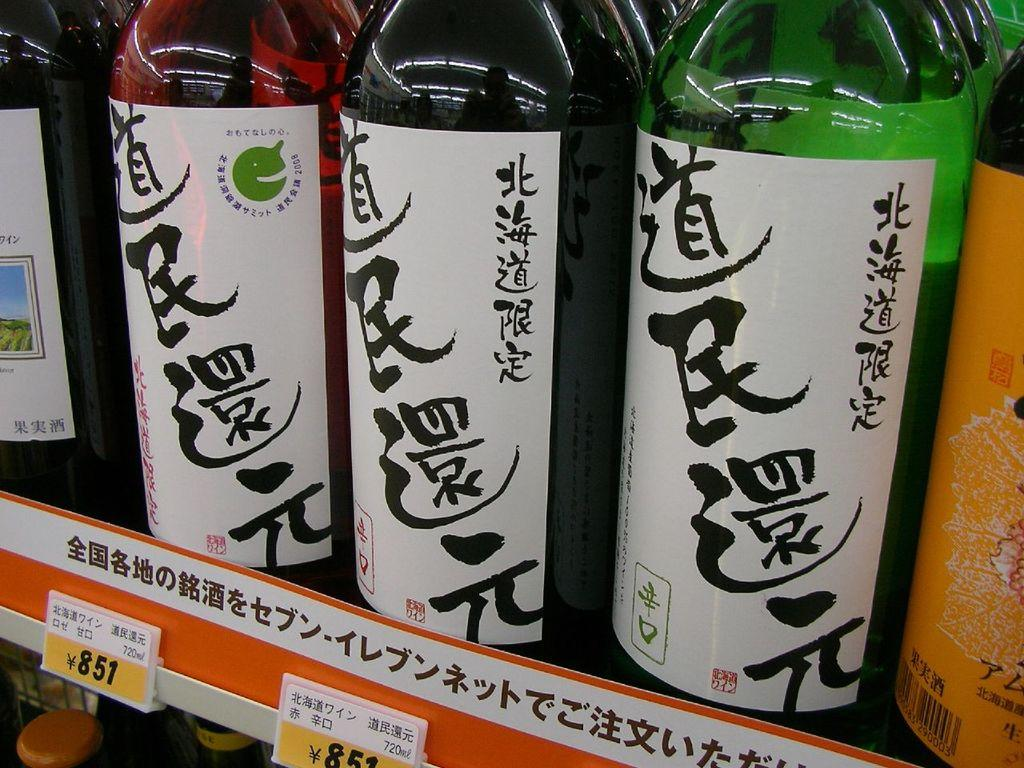<image>
Give a short and clear explanation of the subsequent image. Yellow and white tag on front of shelve with 851 printed on it. 